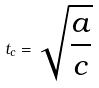<formula> <loc_0><loc_0><loc_500><loc_500>t _ { c } = \sqrt { \frac { a } { c } }</formula> 